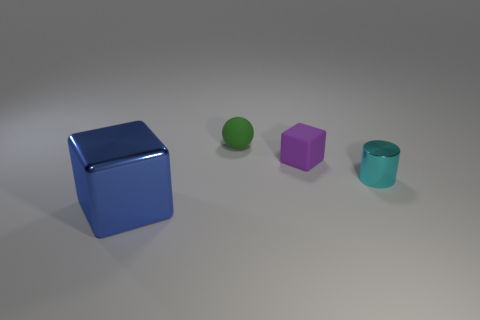Add 2 purple rubber things. How many objects exist? 6 Subtract all cylinders. How many objects are left? 3 Add 1 green rubber things. How many green rubber things are left? 2 Add 4 cylinders. How many cylinders exist? 5 Subtract 0 yellow balls. How many objects are left? 4 Subtract all small cyan cylinders. Subtract all tiny objects. How many objects are left? 0 